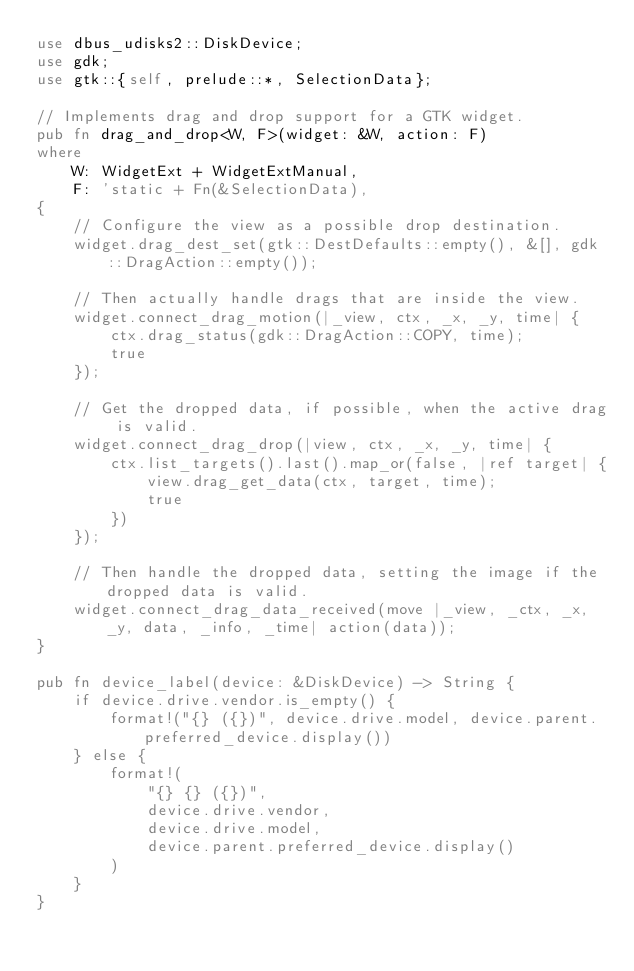<code> <loc_0><loc_0><loc_500><loc_500><_Rust_>use dbus_udisks2::DiskDevice;
use gdk;
use gtk::{self, prelude::*, SelectionData};

// Implements drag and drop support for a GTK widget.
pub fn drag_and_drop<W, F>(widget: &W, action: F)
where
    W: WidgetExt + WidgetExtManual,
    F: 'static + Fn(&SelectionData),
{
    // Configure the view as a possible drop destination.
    widget.drag_dest_set(gtk::DestDefaults::empty(), &[], gdk::DragAction::empty());

    // Then actually handle drags that are inside the view.
    widget.connect_drag_motion(|_view, ctx, _x, _y, time| {
        ctx.drag_status(gdk::DragAction::COPY, time);
        true
    });

    // Get the dropped data, if possible, when the active drag is valid.
    widget.connect_drag_drop(|view, ctx, _x, _y, time| {
        ctx.list_targets().last().map_or(false, |ref target| {
            view.drag_get_data(ctx, target, time);
            true
        })
    });

    // Then handle the dropped data, setting the image if the dropped data is valid.
    widget.connect_drag_data_received(move |_view, _ctx, _x, _y, data, _info, _time| action(data));
}

pub fn device_label(device: &DiskDevice) -> String {
    if device.drive.vendor.is_empty() {
        format!("{} ({})", device.drive.model, device.parent.preferred_device.display())
    } else {
        format!(
            "{} {} ({})",
            device.drive.vendor,
            device.drive.model,
            device.parent.preferred_device.display()
        )
    }
}
</code> 